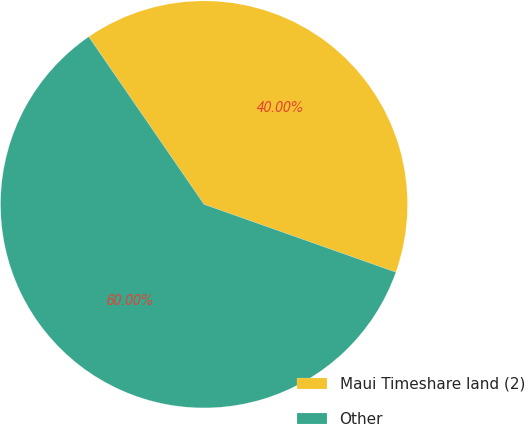Convert chart to OTSL. <chart><loc_0><loc_0><loc_500><loc_500><pie_chart><fcel>Maui Timeshare land (2)<fcel>Other<nl><fcel>40.0%<fcel>60.0%<nl></chart> 